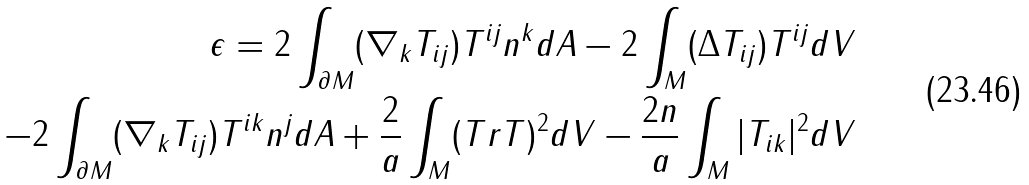<formula> <loc_0><loc_0><loc_500><loc_500>\epsilon = 2 \int _ { \partial M } ( \nabla _ { k } T _ { i j } ) T ^ { i j } n ^ { k } d A - 2 \int _ { M } ( \Delta T _ { i j } ) T ^ { i j } d V \\ - 2 \int _ { \partial M } ( \nabla _ { k } T _ { i j } ) T ^ { i k } n ^ { j } d A + \frac { 2 } { a } \int _ { M } ( T r T ) ^ { 2 } d V - \frac { 2 n } { a } \int _ { M } | T _ { i k } | ^ { 2 } d V</formula> 